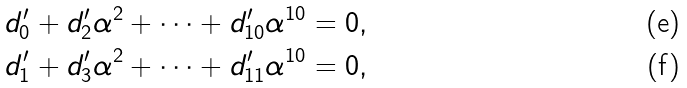Convert formula to latex. <formula><loc_0><loc_0><loc_500><loc_500>d ^ { \prime } _ { 0 } & + d ^ { \prime } _ { 2 } \alpha ^ { 2 } + \cdots + d ^ { \prime } _ { 1 0 } \alpha ^ { 1 0 } = 0 , \\ d ^ { \prime } _ { 1 } & + d ^ { \prime } _ { 3 } \alpha ^ { 2 } + \cdots + d ^ { \prime } _ { 1 1 } \alpha ^ { 1 0 } = 0 ,</formula> 